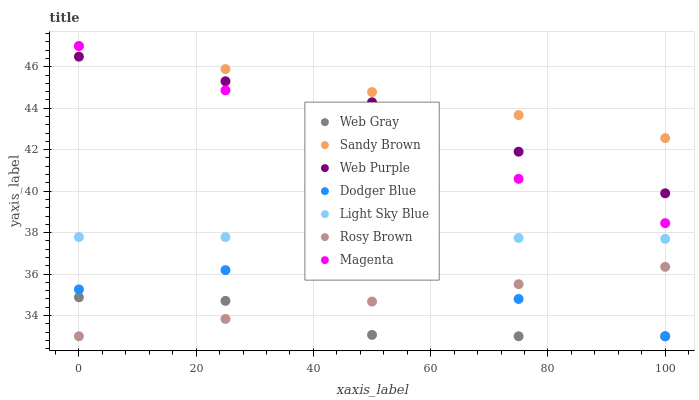Does Web Gray have the minimum area under the curve?
Answer yes or no. Yes. Does Sandy Brown have the maximum area under the curve?
Answer yes or no. Yes. Does Rosy Brown have the minimum area under the curve?
Answer yes or no. No. Does Rosy Brown have the maximum area under the curve?
Answer yes or no. No. Is Magenta the smoothest?
Answer yes or no. Yes. Is Web Gray the roughest?
Answer yes or no. Yes. Is Rosy Brown the smoothest?
Answer yes or no. No. Is Rosy Brown the roughest?
Answer yes or no. No. Does Web Gray have the lowest value?
Answer yes or no. Yes. Does Web Purple have the lowest value?
Answer yes or no. No. Does Sandy Brown have the highest value?
Answer yes or no. Yes. Does Rosy Brown have the highest value?
Answer yes or no. No. Is Light Sky Blue less than Web Purple?
Answer yes or no. Yes. Is Magenta greater than Light Sky Blue?
Answer yes or no. Yes. Does Web Purple intersect Magenta?
Answer yes or no. Yes. Is Web Purple less than Magenta?
Answer yes or no. No. Is Web Purple greater than Magenta?
Answer yes or no. No. Does Light Sky Blue intersect Web Purple?
Answer yes or no. No. 